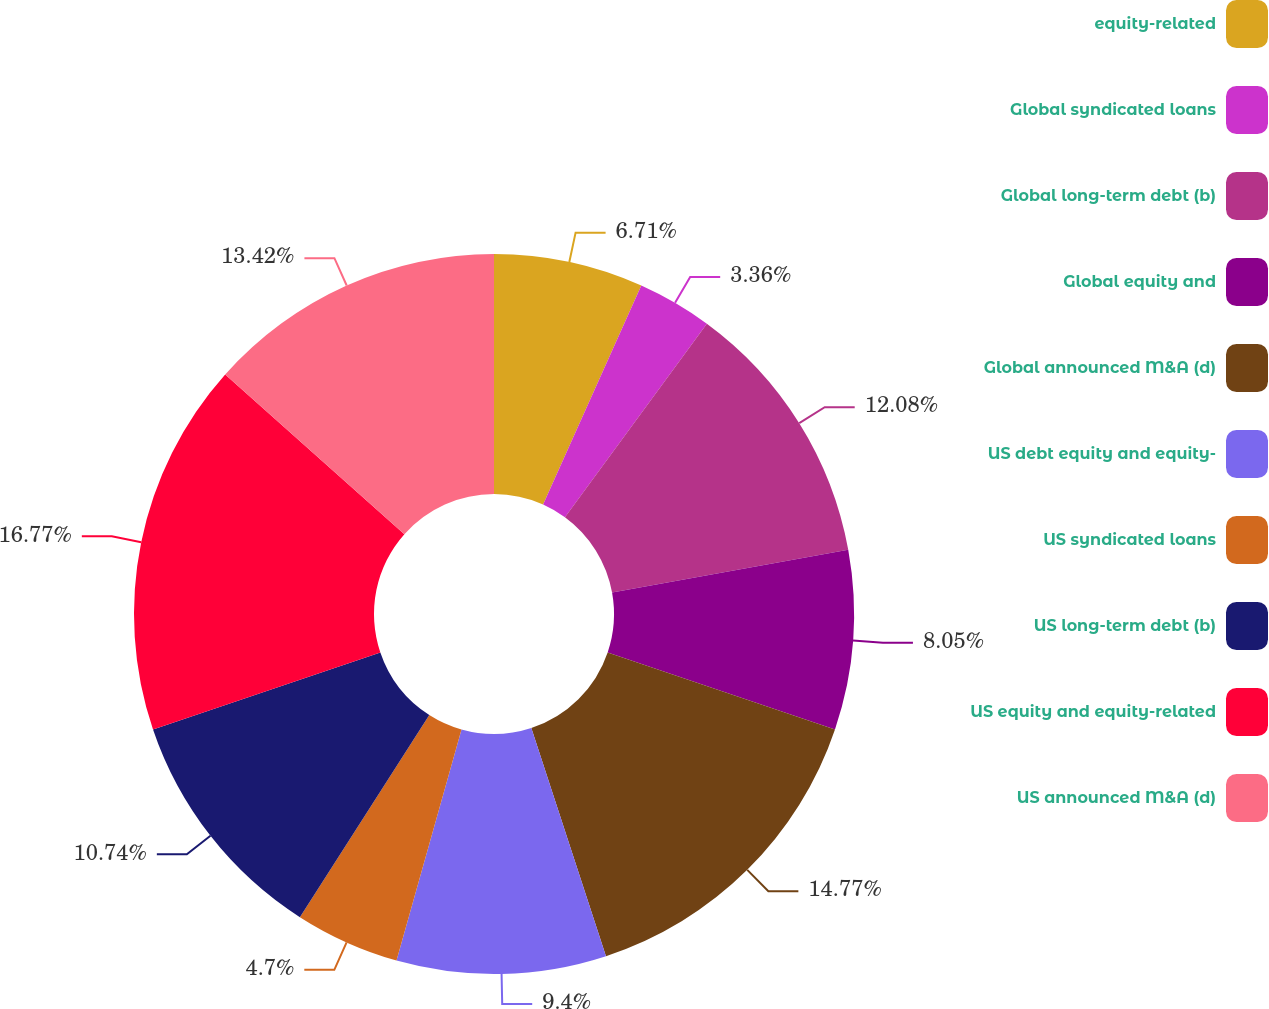Convert chart. <chart><loc_0><loc_0><loc_500><loc_500><pie_chart><fcel>equity-related<fcel>Global syndicated loans<fcel>Global long-term debt (b)<fcel>Global equity and<fcel>Global announced M&A (d)<fcel>US debt equity and equity-<fcel>US syndicated loans<fcel>US long-term debt (b)<fcel>US equity and equity-related<fcel>US announced M&A (d)<nl><fcel>6.71%<fcel>3.36%<fcel>12.08%<fcel>8.05%<fcel>14.77%<fcel>9.4%<fcel>4.7%<fcel>10.74%<fcel>16.78%<fcel>13.42%<nl></chart> 